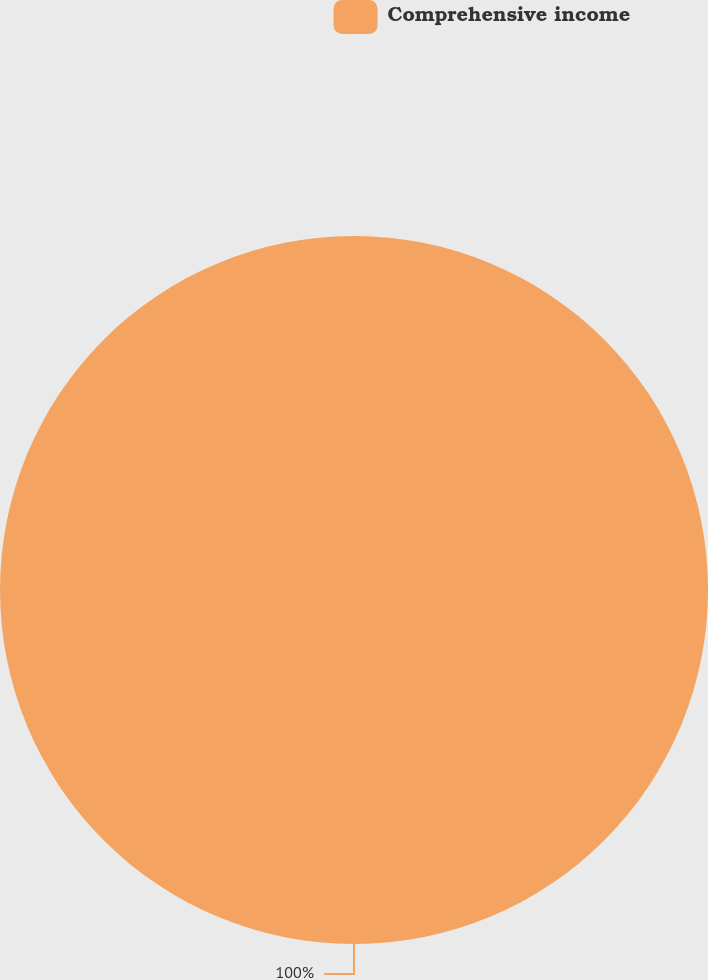<chart> <loc_0><loc_0><loc_500><loc_500><pie_chart><fcel>Comprehensive income<nl><fcel>100.0%<nl></chart> 